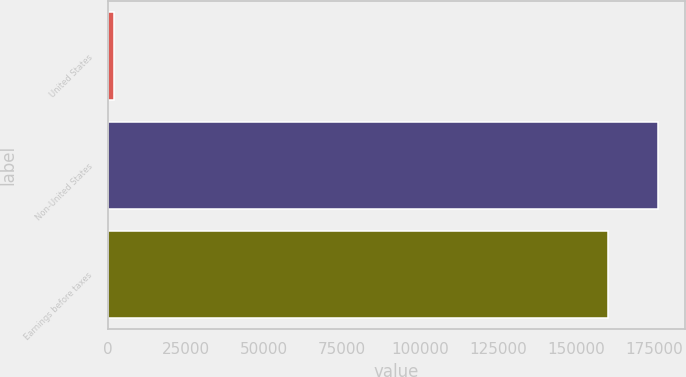Convert chart to OTSL. <chart><loc_0><loc_0><loc_500><loc_500><bar_chart><fcel>United States<fcel>Non-United States<fcel>Earnings before taxes<nl><fcel>1955<fcel>176202<fcel>160184<nl></chart> 